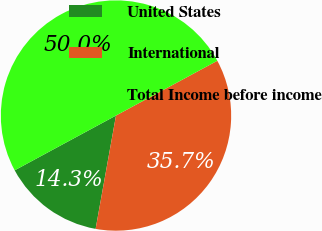Convert chart to OTSL. <chart><loc_0><loc_0><loc_500><loc_500><pie_chart><fcel>United States<fcel>International<fcel>Total Income before income<nl><fcel>14.28%<fcel>35.72%<fcel>50.0%<nl></chart> 